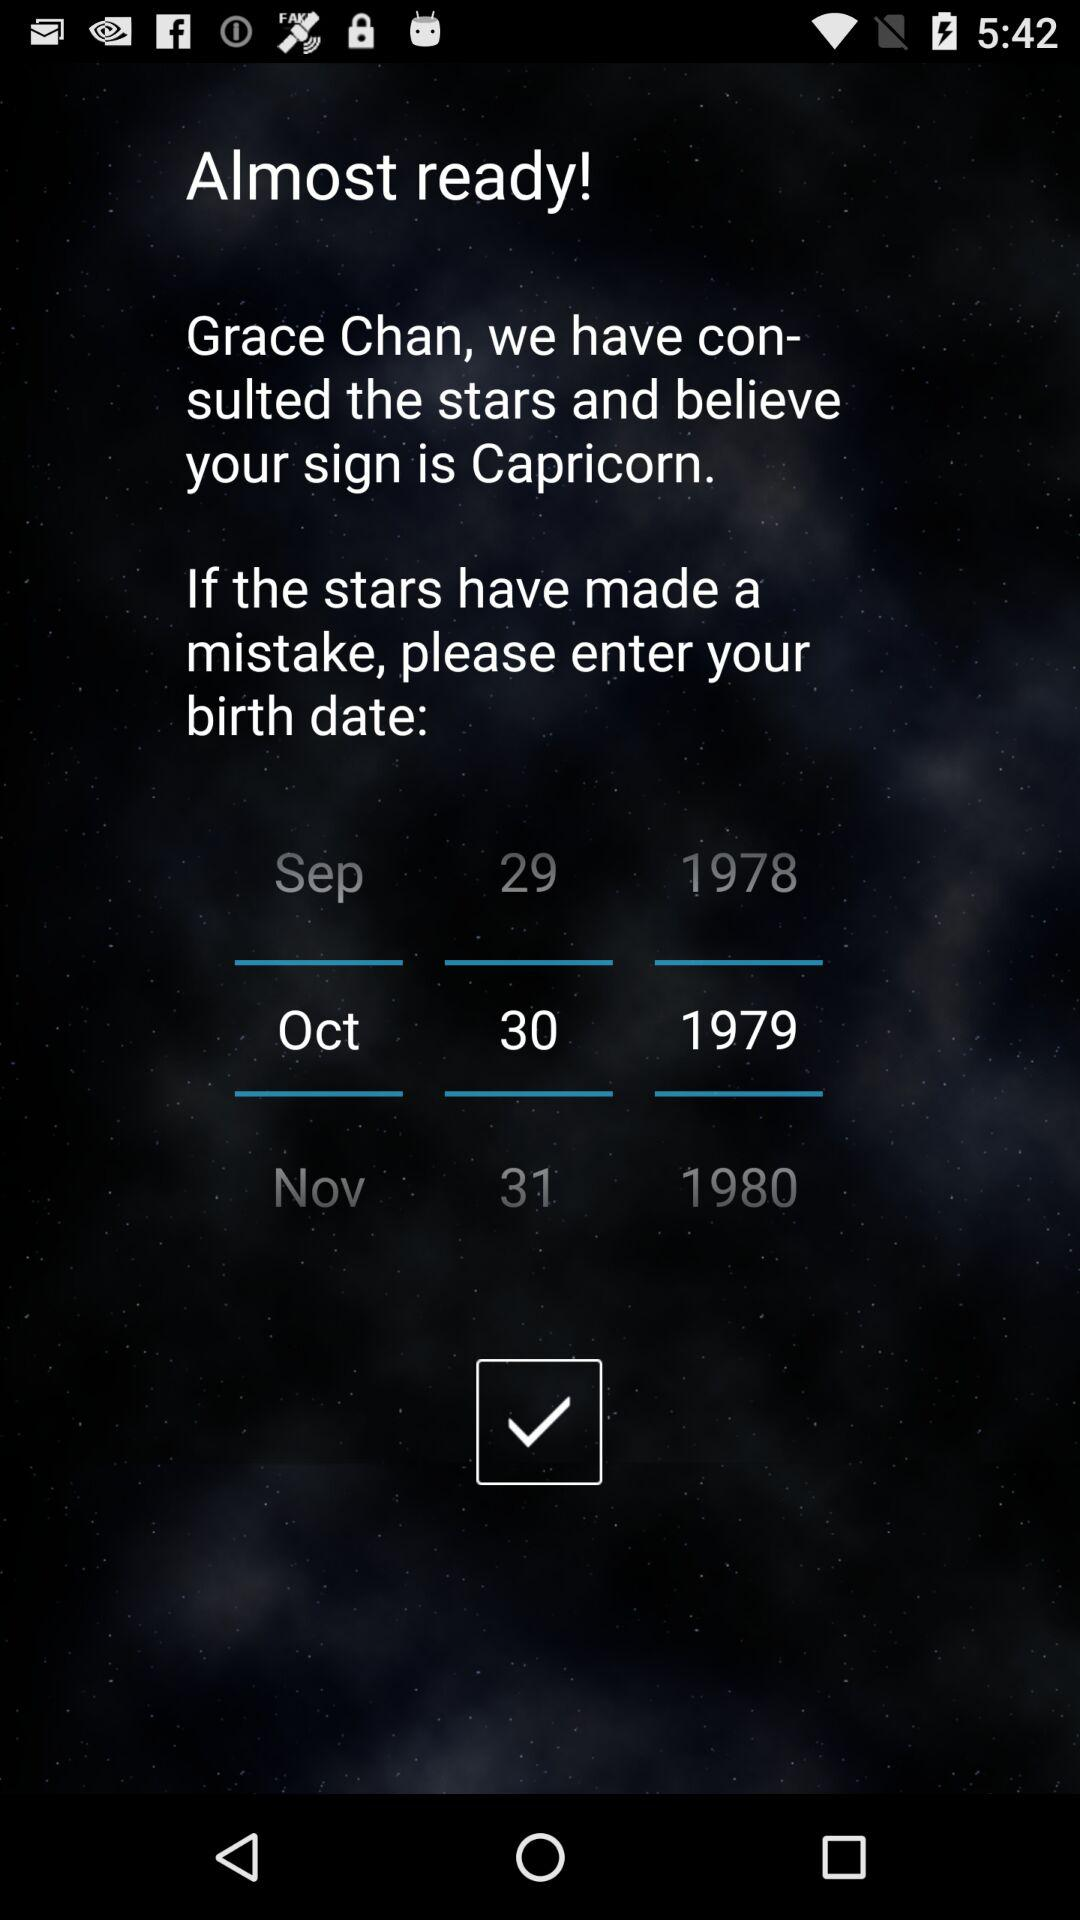What is the selected date of birth? The selected date of birth is October 30, 1979. 